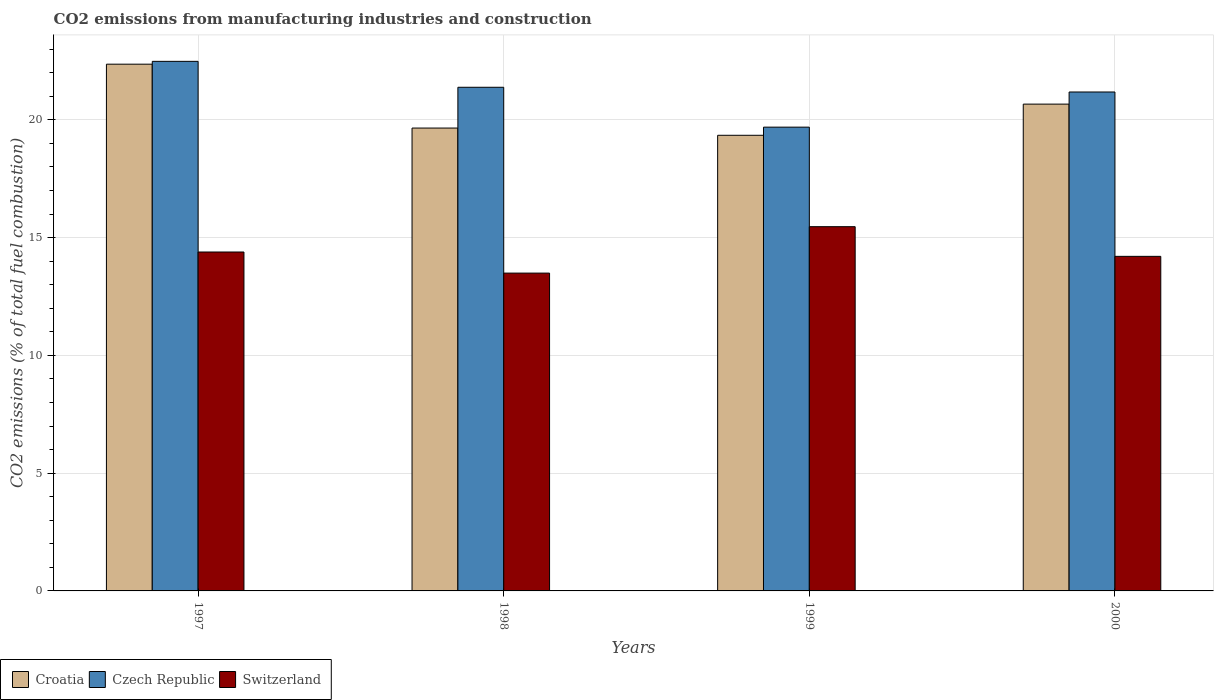How many different coloured bars are there?
Ensure brevity in your answer.  3. How many groups of bars are there?
Provide a succinct answer. 4. Are the number of bars on each tick of the X-axis equal?
Your response must be concise. Yes. What is the label of the 2nd group of bars from the left?
Offer a very short reply. 1998. What is the amount of CO2 emitted in Switzerland in 1997?
Your answer should be compact. 14.39. Across all years, what is the maximum amount of CO2 emitted in Switzerland?
Make the answer very short. 15.46. Across all years, what is the minimum amount of CO2 emitted in Czech Republic?
Offer a very short reply. 19.69. In which year was the amount of CO2 emitted in Switzerland maximum?
Ensure brevity in your answer.  1999. In which year was the amount of CO2 emitted in Czech Republic minimum?
Offer a terse response. 1999. What is the total amount of CO2 emitted in Switzerland in the graph?
Your answer should be very brief. 57.55. What is the difference between the amount of CO2 emitted in Czech Republic in 1997 and that in 1999?
Your answer should be compact. 2.79. What is the difference between the amount of CO2 emitted in Croatia in 1998 and the amount of CO2 emitted in Czech Republic in 1999?
Ensure brevity in your answer.  -0.04. What is the average amount of CO2 emitted in Czech Republic per year?
Provide a succinct answer. 21.18. In the year 2000, what is the difference between the amount of CO2 emitted in Switzerland and amount of CO2 emitted in Croatia?
Offer a very short reply. -6.46. What is the ratio of the amount of CO2 emitted in Czech Republic in 1998 to that in 2000?
Offer a terse response. 1.01. What is the difference between the highest and the second highest amount of CO2 emitted in Switzerland?
Ensure brevity in your answer.  1.08. What is the difference between the highest and the lowest amount of CO2 emitted in Croatia?
Offer a terse response. 3.02. In how many years, is the amount of CO2 emitted in Switzerland greater than the average amount of CO2 emitted in Switzerland taken over all years?
Provide a short and direct response. 2. Is the sum of the amount of CO2 emitted in Switzerland in 1997 and 2000 greater than the maximum amount of CO2 emitted in Czech Republic across all years?
Offer a terse response. Yes. What does the 3rd bar from the left in 1997 represents?
Ensure brevity in your answer.  Switzerland. What does the 1st bar from the right in 1999 represents?
Provide a succinct answer. Switzerland. Is it the case that in every year, the sum of the amount of CO2 emitted in Croatia and amount of CO2 emitted in Switzerland is greater than the amount of CO2 emitted in Czech Republic?
Keep it short and to the point. Yes. How many years are there in the graph?
Provide a succinct answer. 4. Where does the legend appear in the graph?
Offer a very short reply. Bottom left. How many legend labels are there?
Make the answer very short. 3. What is the title of the graph?
Ensure brevity in your answer.  CO2 emissions from manufacturing industries and construction. What is the label or title of the Y-axis?
Provide a succinct answer. CO2 emissions (% of total fuel combustion). What is the CO2 emissions (% of total fuel combustion) in Croatia in 1997?
Your response must be concise. 22.36. What is the CO2 emissions (% of total fuel combustion) of Czech Republic in 1997?
Offer a terse response. 22.48. What is the CO2 emissions (% of total fuel combustion) in Switzerland in 1997?
Your response must be concise. 14.39. What is the CO2 emissions (% of total fuel combustion) of Croatia in 1998?
Ensure brevity in your answer.  19.65. What is the CO2 emissions (% of total fuel combustion) of Czech Republic in 1998?
Keep it short and to the point. 21.38. What is the CO2 emissions (% of total fuel combustion) of Switzerland in 1998?
Ensure brevity in your answer.  13.49. What is the CO2 emissions (% of total fuel combustion) in Croatia in 1999?
Offer a very short reply. 19.34. What is the CO2 emissions (% of total fuel combustion) of Czech Republic in 1999?
Offer a very short reply. 19.69. What is the CO2 emissions (% of total fuel combustion) in Switzerland in 1999?
Give a very brief answer. 15.46. What is the CO2 emissions (% of total fuel combustion) in Croatia in 2000?
Your response must be concise. 20.67. What is the CO2 emissions (% of total fuel combustion) of Czech Republic in 2000?
Your answer should be very brief. 21.18. What is the CO2 emissions (% of total fuel combustion) of Switzerland in 2000?
Provide a short and direct response. 14.2. Across all years, what is the maximum CO2 emissions (% of total fuel combustion) in Croatia?
Your answer should be compact. 22.36. Across all years, what is the maximum CO2 emissions (% of total fuel combustion) in Czech Republic?
Make the answer very short. 22.48. Across all years, what is the maximum CO2 emissions (% of total fuel combustion) of Switzerland?
Your answer should be compact. 15.46. Across all years, what is the minimum CO2 emissions (% of total fuel combustion) in Croatia?
Your answer should be very brief. 19.34. Across all years, what is the minimum CO2 emissions (% of total fuel combustion) in Czech Republic?
Ensure brevity in your answer.  19.69. Across all years, what is the minimum CO2 emissions (% of total fuel combustion) of Switzerland?
Your answer should be compact. 13.49. What is the total CO2 emissions (% of total fuel combustion) of Croatia in the graph?
Offer a terse response. 82.03. What is the total CO2 emissions (% of total fuel combustion) of Czech Republic in the graph?
Provide a succinct answer. 84.74. What is the total CO2 emissions (% of total fuel combustion) in Switzerland in the graph?
Keep it short and to the point. 57.55. What is the difference between the CO2 emissions (% of total fuel combustion) in Croatia in 1997 and that in 1998?
Offer a terse response. 2.71. What is the difference between the CO2 emissions (% of total fuel combustion) in Czech Republic in 1997 and that in 1998?
Your response must be concise. 1.1. What is the difference between the CO2 emissions (% of total fuel combustion) of Switzerland in 1997 and that in 1998?
Make the answer very short. 0.9. What is the difference between the CO2 emissions (% of total fuel combustion) in Croatia in 1997 and that in 1999?
Your response must be concise. 3.02. What is the difference between the CO2 emissions (% of total fuel combustion) in Czech Republic in 1997 and that in 1999?
Your answer should be very brief. 2.79. What is the difference between the CO2 emissions (% of total fuel combustion) of Switzerland in 1997 and that in 1999?
Ensure brevity in your answer.  -1.08. What is the difference between the CO2 emissions (% of total fuel combustion) in Croatia in 1997 and that in 2000?
Ensure brevity in your answer.  1.7. What is the difference between the CO2 emissions (% of total fuel combustion) of Czech Republic in 1997 and that in 2000?
Provide a succinct answer. 1.3. What is the difference between the CO2 emissions (% of total fuel combustion) of Switzerland in 1997 and that in 2000?
Keep it short and to the point. 0.18. What is the difference between the CO2 emissions (% of total fuel combustion) in Croatia in 1998 and that in 1999?
Offer a terse response. 0.31. What is the difference between the CO2 emissions (% of total fuel combustion) of Czech Republic in 1998 and that in 1999?
Ensure brevity in your answer.  1.69. What is the difference between the CO2 emissions (% of total fuel combustion) in Switzerland in 1998 and that in 1999?
Provide a succinct answer. -1.97. What is the difference between the CO2 emissions (% of total fuel combustion) of Croatia in 1998 and that in 2000?
Your answer should be very brief. -1.02. What is the difference between the CO2 emissions (% of total fuel combustion) in Czech Republic in 1998 and that in 2000?
Give a very brief answer. 0.2. What is the difference between the CO2 emissions (% of total fuel combustion) of Switzerland in 1998 and that in 2000?
Your answer should be compact. -0.71. What is the difference between the CO2 emissions (% of total fuel combustion) in Croatia in 1999 and that in 2000?
Give a very brief answer. -1.32. What is the difference between the CO2 emissions (% of total fuel combustion) of Czech Republic in 1999 and that in 2000?
Offer a terse response. -1.49. What is the difference between the CO2 emissions (% of total fuel combustion) in Switzerland in 1999 and that in 2000?
Give a very brief answer. 1.26. What is the difference between the CO2 emissions (% of total fuel combustion) of Croatia in 1997 and the CO2 emissions (% of total fuel combustion) of Czech Republic in 1998?
Your answer should be compact. 0.98. What is the difference between the CO2 emissions (% of total fuel combustion) in Croatia in 1997 and the CO2 emissions (% of total fuel combustion) in Switzerland in 1998?
Provide a short and direct response. 8.87. What is the difference between the CO2 emissions (% of total fuel combustion) of Czech Republic in 1997 and the CO2 emissions (% of total fuel combustion) of Switzerland in 1998?
Your answer should be compact. 8.99. What is the difference between the CO2 emissions (% of total fuel combustion) of Croatia in 1997 and the CO2 emissions (% of total fuel combustion) of Czech Republic in 1999?
Offer a very short reply. 2.67. What is the difference between the CO2 emissions (% of total fuel combustion) of Croatia in 1997 and the CO2 emissions (% of total fuel combustion) of Switzerland in 1999?
Provide a short and direct response. 6.9. What is the difference between the CO2 emissions (% of total fuel combustion) of Czech Republic in 1997 and the CO2 emissions (% of total fuel combustion) of Switzerland in 1999?
Provide a succinct answer. 7.02. What is the difference between the CO2 emissions (% of total fuel combustion) of Croatia in 1997 and the CO2 emissions (% of total fuel combustion) of Czech Republic in 2000?
Your response must be concise. 1.18. What is the difference between the CO2 emissions (% of total fuel combustion) in Croatia in 1997 and the CO2 emissions (% of total fuel combustion) in Switzerland in 2000?
Offer a very short reply. 8.16. What is the difference between the CO2 emissions (% of total fuel combustion) of Czech Republic in 1997 and the CO2 emissions (% of total fuel combustion) of Switzerland in 2000?
Provide a short and direct response. 8.28. What is the difference between the CO2 emissions (% of total fuel combustion) in Croatia in 1998 and the CO2 emissions (% of total fuel combustion) in Czech Republic in 1999?
Ensure brevity in your answer.  -0.04. What is the difference between the CO2 emissions (% of total fuel combustion) in Croatia in 1998 and the CO2 emissions (% of total fuel combustion) in Switzerland in 1999?
Your answer should be compact. 4.19. What is the difference between the CO2 emissions (% of total fuel combustion) of Czech Republic in 1998 and the CO2 emissions (% of total fuel combustion) of Switzerland in 1999?
Ensure brevity in your answer.  5.92. What is the difference between the CO2 emissions (% of total fuel combustion) of Croatia in 1998 and the CO2 emissions (% of total fuel combustion) of Czech Republic in 2000?
Offer a terse response. -1.53. What is the difference between the CO2 emissions (% of total fuel combustion) in Croatia in 1998 and the CO2 emissions (% of total fuel combustion) in Switzerland in 2000?
Keep it short and to the point. 5.45. What is the difference between the CO2 emissions (% of total fuel combustion) in Czech Republic in 1998 and the CO2 emissions (% of total fuel combustion) in Switzerland in 2000?
Your answer should be compact. 7.18. What is the difference between the CO2 emissions (% of total fuel combustion) in Croatia in 1999 and the CO2 emissions (% of total fuel combustion) in Czech Republic in 2000?
Keep it short and to the point. -1.84. What is the difference between the CO2 emissions (% of total fuel combustion) in Croatia in 1999 and the CO2 emissions (% of total fuel combustion) in Switzerland in 2000?
Your answer should be compact. 5.14. What is the difference between the CO2 emissions (% of total fuel combustion) of Czech Republic in 1999 and the CO2 emissions (% of total fuel combustion) of Switzerland in 2000?
Your answer should be very brief. 5.49. What is the average CO2 emissions (% of total fuel combustion) of Croatia per year?
Make the answer very short. 20.51. What is the average CO2 emissions (% of total fuel combustion) in Czech Republic per year?
Make the answer very short. 21.18. What is the average CO2 emissions (% of total fuel combustion) of Switzerland per year?
Keep it short and to the point. 14.39. In the year 1997, what is the difference between the CO2 emissions (% of total fuel combustion) of Croatia and CO2 emissions (% of total fuel combustion) of Czech Republic?
Make the answer very short. -0.12. In the year 1997, what is the difference between the CO2 emissions (% of total fuel combustion) in Croatia and CO2 emissions (% of total fuel combustion) in Switzerland?
Offer a very short reply. 7.97. In the year 1997, what is the difference between the CO2 emissions (% of total fuel combustion) of Czech Republic and CO2 emissions (% of total fuel combustion) of Switzerland?
Your answer should be compact. 8.09. In the year 1998, what is the difference between the CO2 emissions (% of total fuel combustion) in Croatia and CO2 emissions (% of total fuel combustion) in Czech Republic?
Give a very brief answer. -1.73. In the year 1998, what is the difference between the CO2 emissions (% of total fuel combustion) of Croatia and CO2 emissions (% of total fuel combustion) of Switzerland?
Give a very brief answer. 6.16. In the year 1998, what is the difference between the CO2 emissions (% of total fuel combustion) of Czech Republic and CO2 emissions (% of total fuel combustion) of Switzerland?
Offer a terse response. 7.89. In the year 1999, what is the difference between the CO2 emissions (% of total fuel combustion) in Croatia and CO2 emissions (% of total fuel combustion) in Czech Republic?
Offer a terse response. -0.35. In the year 1999, what is the difference between the CO2 emissions (% of total fuel combustion) in Croatia and CO2 emissions (% of total fuel combustion) in Switzerland?
Your answer should be compact. 3.88. In the year 1999, what is the difference between the CO2 emissions (% of total fuel combustion) of Czech Republic and CO2 emissions (% of total fuel combustion) of Switzerland?
Your answer should be very brief. 4.23. In the year 2000, what is the difference between the CO2 emissions (% of total fuel combustion) in Croatia and CO2 emissions (% of total fuel combustion) in Czech Republic?
Give a very brief answer. -0.51. In the year 2000, what is the difference between the CO2 emissions (% of total fuel combustion) in Croatia and CO2 emissions (% of total fuel combustion) in Switzerland?
Ensure brevity in your answer.  6.46. In the year 2000, what is the difference between the CO2 emissions (% of total fuel combustion) in Czech Republic and CO2 emissions (% of total fuel combustion) in Switzerland?
Make the answer very short. 6.98. What is the ratio of the CO2 emissions (% of total fuel combustion) of Croatia in 1997 to that in 1998?
Your answer should be very brief. 1.14. What is the ratio of the CO2 emissions (% of total fuel combustion) in Czech Republic in 1997 to that in 1998?
Your answer should be compact. 1.05. What is the ratio of the CO2 emissions (% of total fuel combustion) of Switzerland in 1997 to that in 1998?
Your response must be concise. 1.07. What is the ratio of the CO2 emissions (% of total fuel combustion) of Croatia in 1997 to that in 1999?
Make the answer very short. 1.16. What is the ratio of the CO2 emissions (% of total fuel combustion) in Czech Republic in 1997 to that in 1999?
Keep it short and to the point. 1.14. What is the ratio of the CO2 emissions (% of total fuel combustion) in Switzerland in 1997 to that in 1999?
Keep it short and to the point. 0.93. What is the ratio of the CO2 emissions (% of total fuel combustion) in Croatia in 1997 to that in 2000?
Provide a short and direct response. 1.08. What is the ratio of the CO2 emissions (% of total fuel combustion) of Czech Republic in 1997 to that in 2000?
Give a very brief answer. 1.06. What is the ratio of the CO2 emissions (% of total fuel combustion) of Croatia in 1998 to that in 1999?
Make the answer very short. 1.02. What is the ratio of the CO2 emissions (% of total fuel combustion) in Czech Republic in 1998 to that in 1999?
Give a very brief answer. 1.09. What is the ratio of the CO2 emissions (% of total fuel combustion) in Switzerland in 1998 to that in 1999?
Ensure brevity in your answer.  0.87. What is the ratio of the CO2 emissions (% of total fuel combustion) of Croatia in 1998 to that in 2000?
Your answer should be compact. 0.95. What is the ratio of the CO2 emissions (% of total fuel combustion) in Czech Republic in 1998 to that in 2000?
Ensure brevity in your answer.  1.01. What is the ratio of the CO2 emissions (% of total fuel combustion) of Switzerland in 1998 to that in 2000?
Offer a very short reply. 0.95. What is the ratio of the CO2 emissions (% of total fuel combustion) in Croatia in 1999 to that in 2000?
Your response must be concise. 0.94. What is the ratio of the CO2 emissions (% of total fuel combustion) in Czech Republic in 1999 to that in 2000?
Provide a short and direct response. 0.93. What is the ratio of the CO2 emissions (% of total fuel combustion) of Switzerland in 1999 to that in 2000?
Give a very brief answer. 1.09. What is the difference between the highest and the second highest CO2 emissions (% of total fuel combustion) in Croatia?
Make the answer very short. 1.7. What is the difference between the highest and the second highest CO2 emissions (% of total fuel combustion) of Czech Republic?
Your response must be concise. 1.1. What is the difference between the highest and the second highest CO2 emissions (% of total fuel combustion) of Switzerland?
Ensure brevity in your answer.  1.08. What is the difference between the highest and the lowest CO2 emissions (% of total fuel combustion) in Croatia?
Your response must be concise. 3.02. What is the difference between the highest and the lowest CO2 emissions (% of total fuel combustion) of Czech Republic?
Provide a short and direct response. 2.79. What is the difference between the highest and the lowest CO2 emissions (% of total fuel combustion) of Switzerland?
Give a very brief answer. 1.97. 